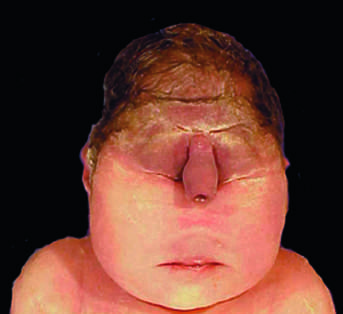what is associated with a lethal malformation, in which the midface structures are fused or ill-formed?
Answer the question using a single word or phrase. Stillbirth 